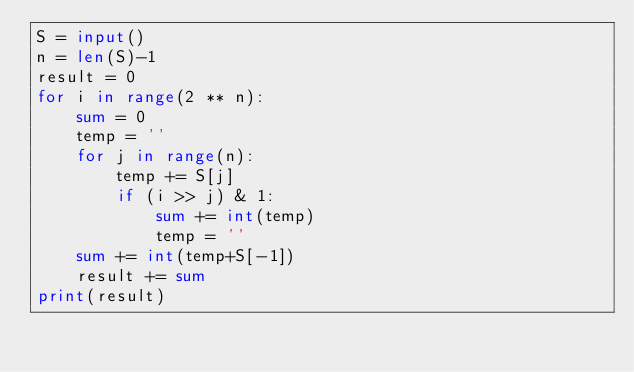<code> <loc_0><loc_0><loc_500><loc_500><_Python_>S = input()
n = len(S)-1
result = 0
for i in range(2 ** n):
    sum = 0
    temp = ''
    for j in range(n):
        temp += S[j]
        if (i >> j) & 1:
            sum += int(temp)
            temp = ''
    sum += int(temp+S[-1])
    result += sum
print(result)</code> 